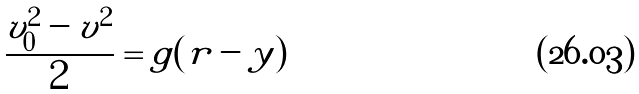<formula> <loc_0><loc_0><loc_500><loc_500>\frac { v _ { 0 } ^ { 2 } - v ^ { 2 } } { 2 } = g ( r - y )</formula> 